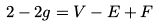Convert formula to latex. <formula><loc_0><loc_0><loc_500><loc_500>2 - 2 g = V - E + F</formula> 